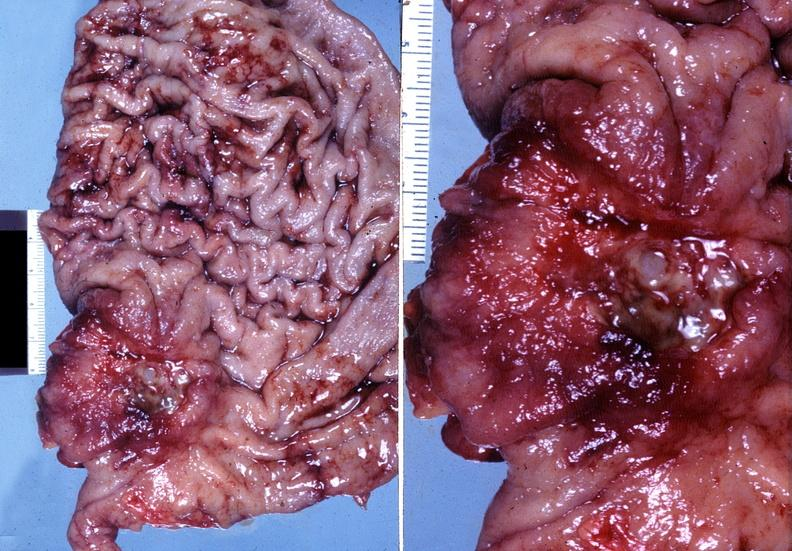s band constriction in skin above ankle of infant present?
Answer the question using a single word or phrase. No 